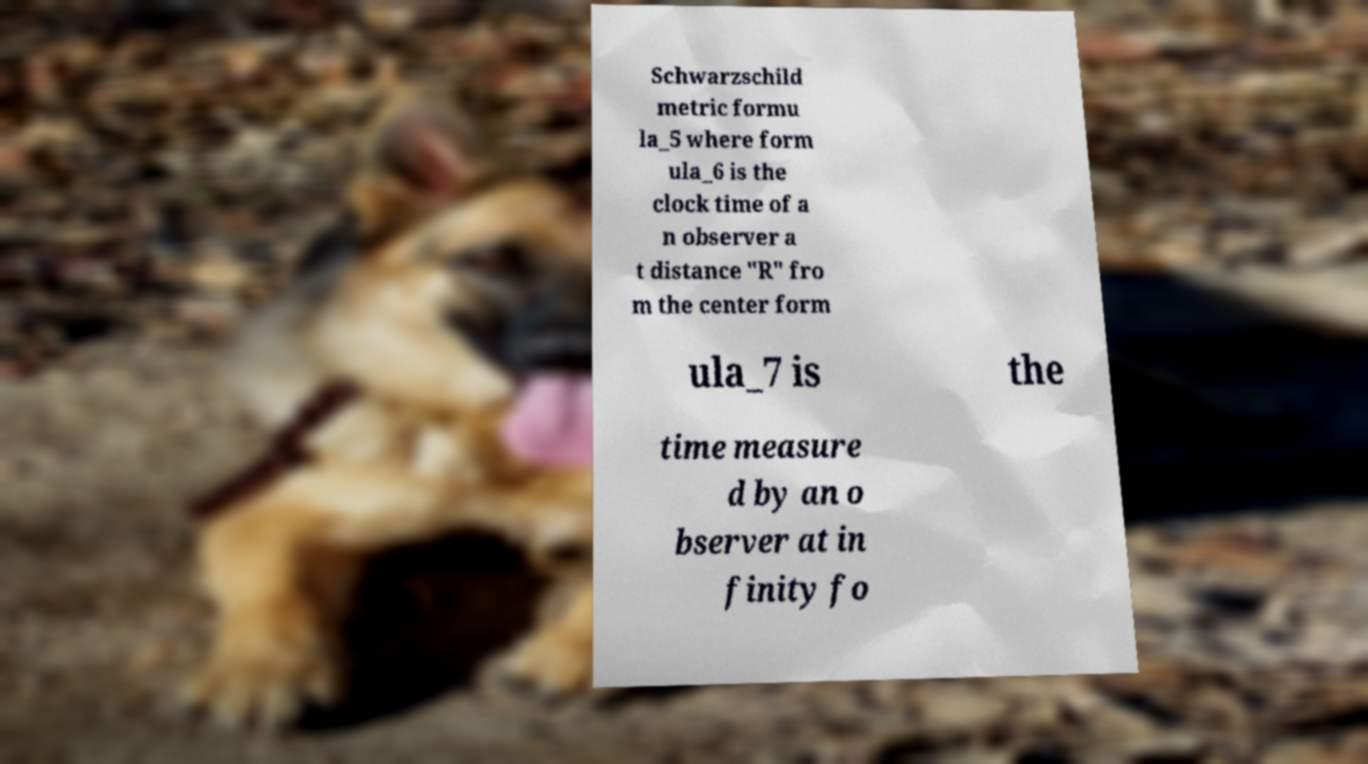Please identify and transcribe the text found in this image. Schwarzschild metric formu la_5 where form ula_6 is the clock time of a n observer a t distance "R" fro m the center form ula_7 is the time measure d by an o bserver at in finity fo 